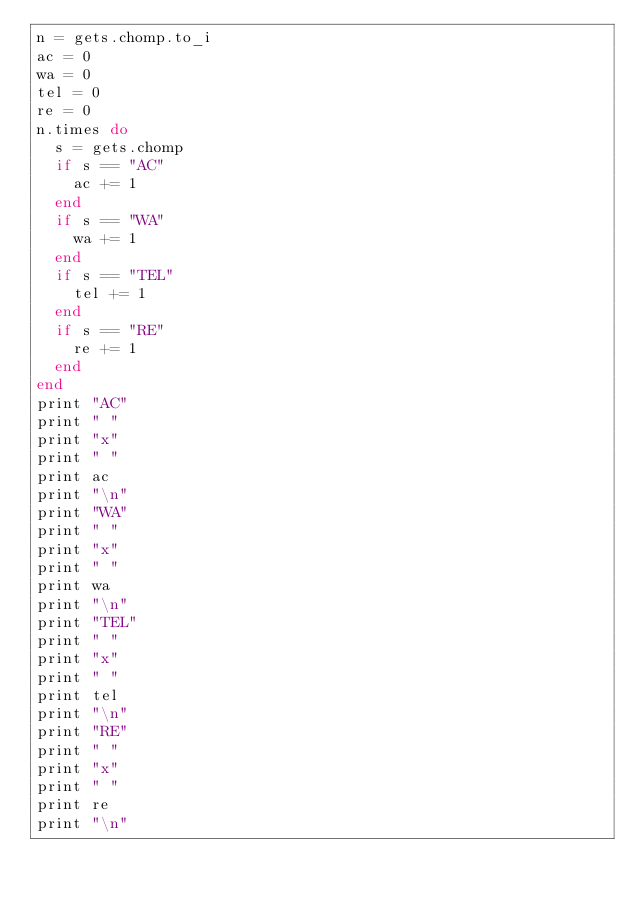Convert code to text. <code><loc_0><loc_0><loc_500><loc_500><_Ruby_>n = gets.chomp.to_i
ac = 0
wa = 0
tel = 0
re = 0
n.times do
  s = gets.chomp
  if s == "AC"
    ac += 1
  end
  if s == "WA"
    wa += 1
  end
  if s == "TEL"
    tel += 1
  end
  if s == "RE"
    re += 1
  end
end
print "AC"
print " "
print "x"
print " "
print ac
print "\n"
print "WA"
print " "
print "x"
print " "
print wa
print "\n"
print "TEL"
print " "
print "x"
print " "
print tel
print "\n"
print "RE"
print " "
print "x"
print " "
print re
print "\n"
</code> 